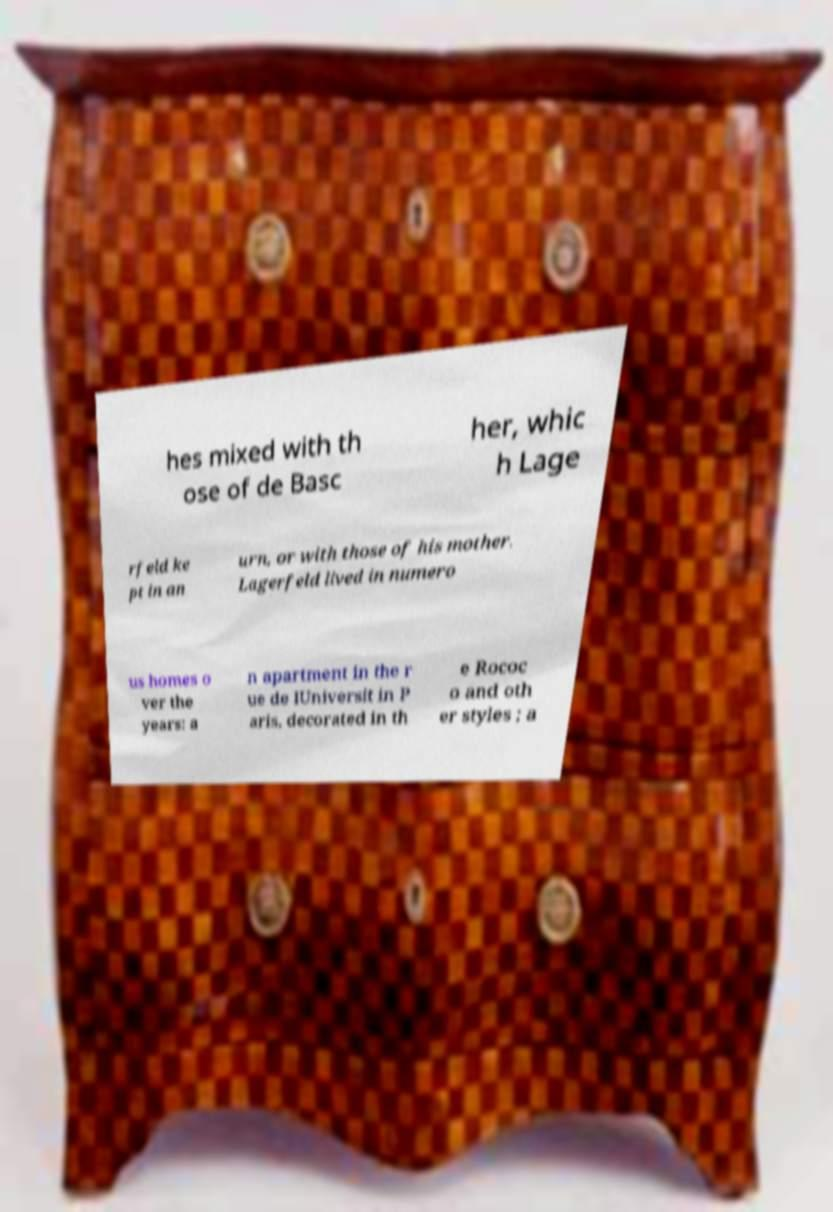Could you assist in decoding the text presented in this image and type it out clearly? hes mixed with th ose of de Basc her, whic h Lage rfeld ke pt in an urn, or with those of his mother. Lagerfeld lived in numero us homes o ver the years: a n apartment in the r ue de lUniversit in P aris, decorated in th e Rococ o and oth er styles ; a 